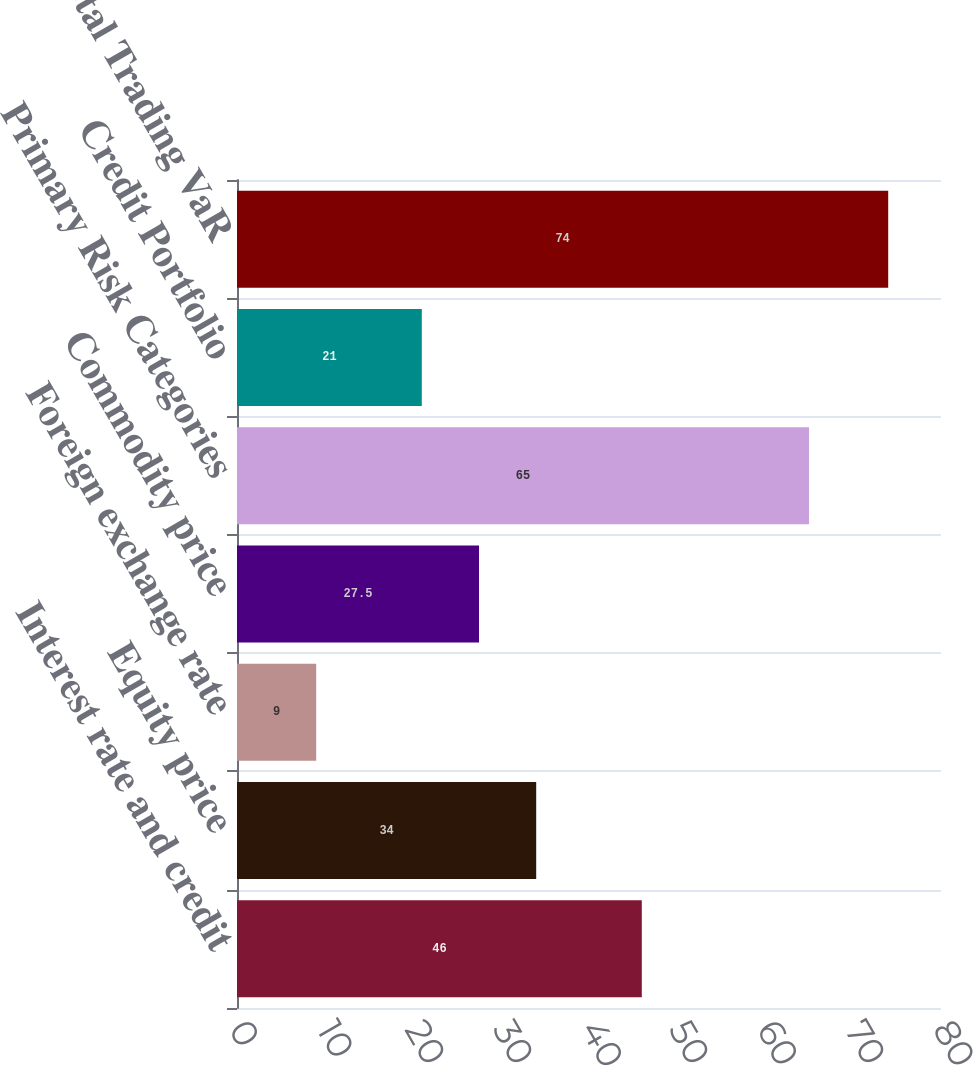<chart> <loc_0><loc_0><loc_500><loc_500><bar_chart><fcel>Interest rate and credit<fcel>Equity price<fcel>Foreign exchange rate<fcel>Commodity price<fcel>Primary Risk Categories<fcel>Credit Portfolio<fcel>Total Trading VaR<nl><fcel>46<fcel>34<fcel>9<fcel>27.5<fcel>65<fcel>21<fcel>74<nl></chart> 